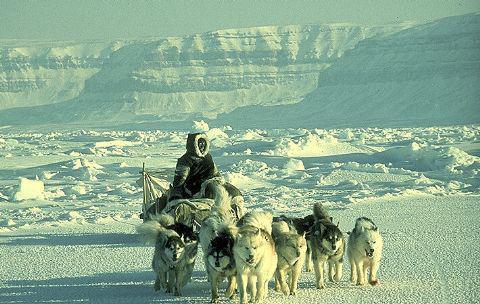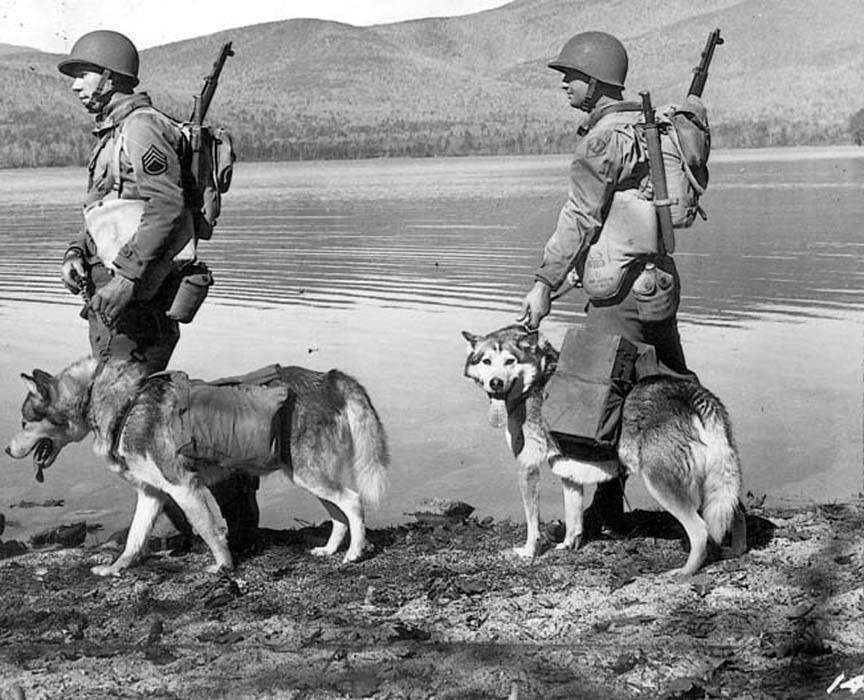The first image is the image on the left, the second image is the image on the right. Assess this claim about the two images: "An image shows a forward-facing person wearing fur, posing next to at least one forward-facing sled dog.". Correct or not? Answer yes or no. No. 